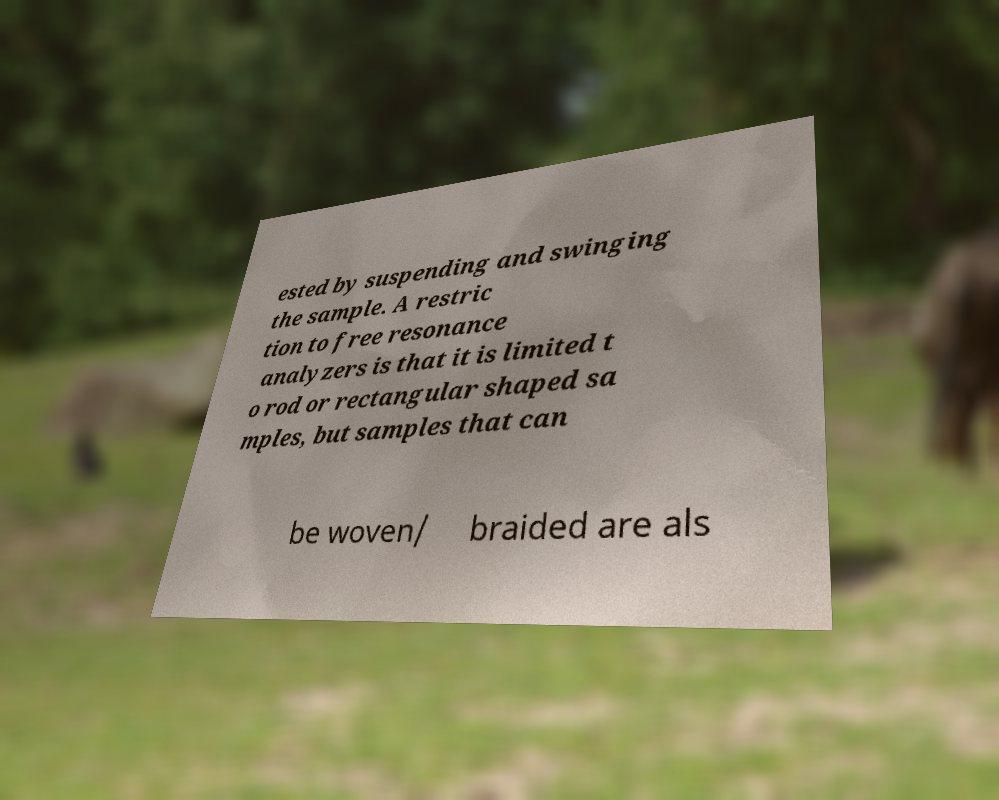Please read and relay the text visible in this image. What does it say? ested by suspending and swinging the sample. A restric tion to free resonance analyzers is that it is limited t o rod or rectangular shaped sa mples, but samples that can be woven/ braided are als 